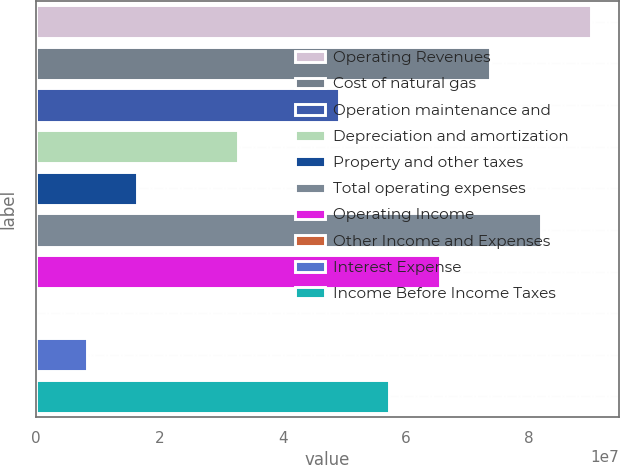<chart> <loc_0><loc_0><loc_500><loc_500><bar_chart><fcel>Operating Revenues<fcel>Cost of natural gas<fcel>Operation maintenance and<fcel>Depreciation and amortization<fcel>Property and other taxes<fcel>Total operating expenses<fcel>Operating Income<fcel>Other Income and Expenses<fcel>Interest Expense<fcel>Income Before Income Taxes<nl><fcel>9.00575e+07<fcel>7.36834e+07<fcel>4.91223e+07<fcel>3.27482e+07<fcel>1.63741e+07<fcel>8.18705e+07<fcel>6.54964e+07<fcel>24<fcel>8.18707e+06<fcel>5.73093e+07<nl></chart> 